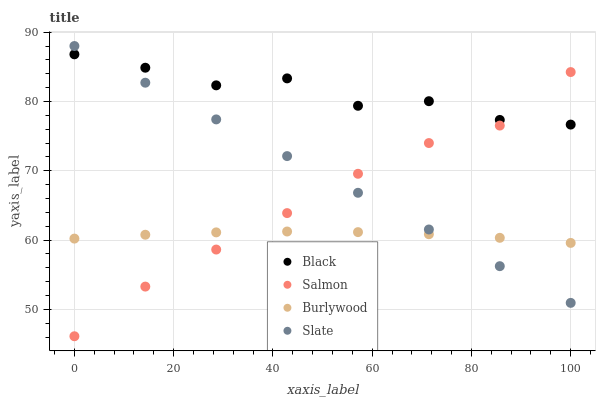Does Burlywood have the minimum area under the curve?
Answer yes or no. Yes. Does Black have the maximum area under the curve?
Answer yes or no. Yes. Does Salmon have the minimum area under the curve?
Answer yes or no. No. Does Salmon have the maximum area under the curve?
Answer yes or no. No. Is Slate the smoothest?
Answer yes or no. Yes. Is Black the roughest?
Answer yes or no. Yes. Is Salmon the smoothest?
Answer yes or no. No. Is Salmon the roughest?
Answer yes or no. No. Does Salmon have the lowest value?
Answer yes or no. Yes. Does Slate have the lowest value?
Answer yes or no. No. Does Slate have the highest value?
Answer yes or no. Yes. Does Salmon have the highest value?
Answer yes or no. No. Is Burlywood less than Black?
Answer yes or no. Yes. Is Black greater than Burlywood?
Answer yes or no. Yes. Does Slate intersect Burlywood?
Answer yes or no. Yes. Is Slate less than Burlywood?
Answer yes or no. No. Is Slate greater than Burlywood?
Answer yes or no. No. Does Burlywood intersect Black?
Answer yes or no. No. 